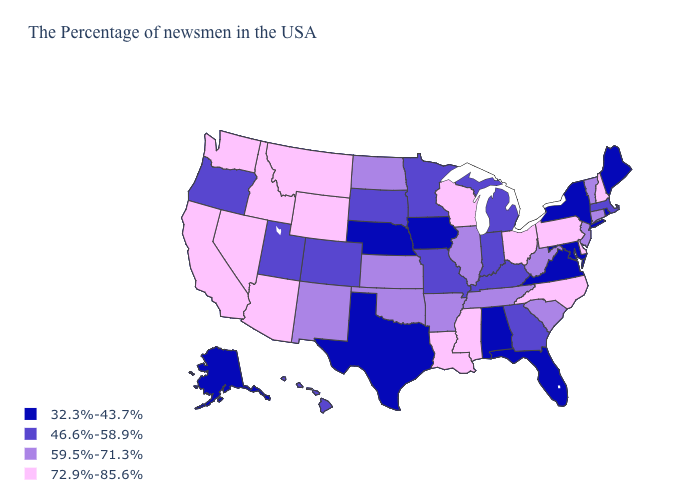Among the states that border Arizona , which have the highest value?
Concise answer only. Nevada, California. Does Washington have the highest value in the West?
Be succinct. Yes. What is the value of Tennessee?
Give a very brief answer. 59.5%-71.3%. Which states have the lowest value in the USA?
Quick response, please. Maine, Rhode Island, New York, Maryland, Virginia, Florida, Alabama, Iowa, Nebraska, Texas, Alaska. Name the states that have a value in the range 72.9%-85.6%?
Quick response, please. New Hampshire, Delaware, Pennsylvania, North Carolina, Ohio, Wisconsin, Mississippi, Louisiana, Wyoming, Montana, Arizona, Idaho, Nevada, California, Washington. Does Oregon have a higher value than South Carolina?
Be succinct. No. What is the highest value in the USA?
Keep it brief. 72.9%-85.6%. What is the value of Utah?
Give a very brief answer. 46.6%-58.9%. What is the lowest value in the USA?
Concise answer only. 32.3%-43.7%. Does Idaho have the highest value in the USA?
Concise answer only. Yes. What is the lowest value in the USA?
Give a very brief answer. 32.3%-43.7%. Does the first symbol in the legend represent the smallest category?
Answer briefly. Yes. Does Texas have the lowest value in the USA?
Quick response, please. Yes. Name the states that have a value in the range 72.9%-85.6%?
Be succinct. New Hampshire, Delaware, Pennsylvania, North Carolina, Ohio, Wisconsin, Mississippi, Louisiana, Wyoming, Montana, Arizona, Idaho, Nevada, California, Washington. What is the value of Nebraska?
Give a very brief answer. 32.3%-43.7%. 